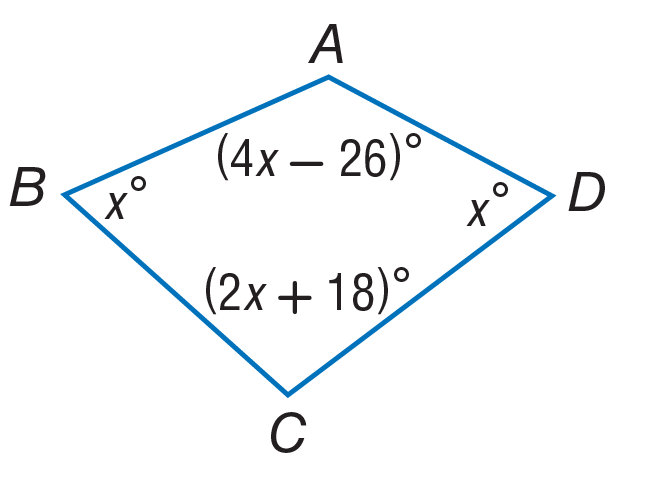Question: Find the measure of \angle B.
Choices:
A. 46
B. 92
C. 110
D. 156
Answer with the letter. Answer: A Question: Find the measure of \angle C.
Choices:
A. 56
B. 110
C. 112
D. 130
Answer with the letter. Answer: B Question: Find the measure of \angle D.
Choices:
A. 46
B. 92
C. 110
D. 143
Answer with the letter. Answer: A 